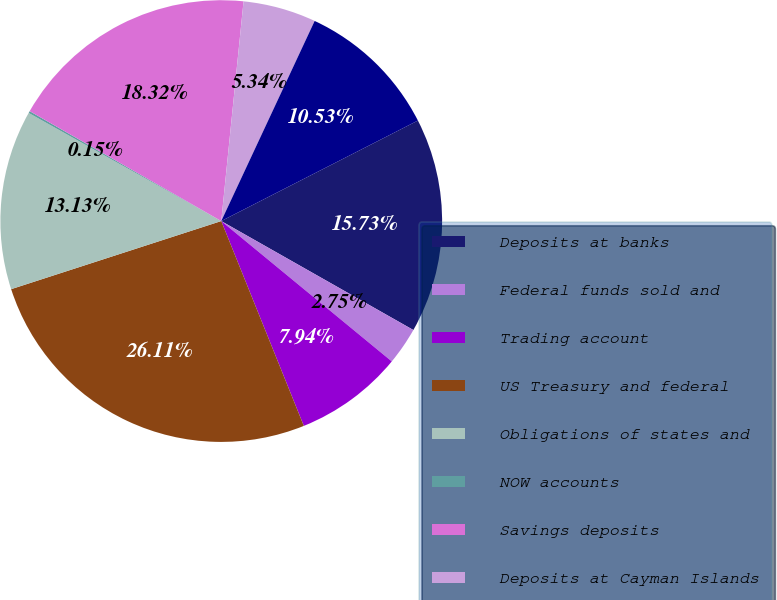<chart> <loc_0><loc_0><loc_500><loc_500><pie_chart><fcel>Deposits at banks<fcel>Federal funds sold and<fcel>Trading account<fcel>US Treasury and federal<fcel>Obligations of states and<fcel>NOW accounts<fcel>Savings deposits<fcel>Deposits at Cayman Islands<fcel>Short-term borrowings<nl><fcel>15.73%<fcel>2.75%<fcel>7.94%<fcel>26.11%<fcel>13.13%<fcel>0.15%<fcel>18.32%<fcel>5.34%<fcel>10.53%<nl></chart> 